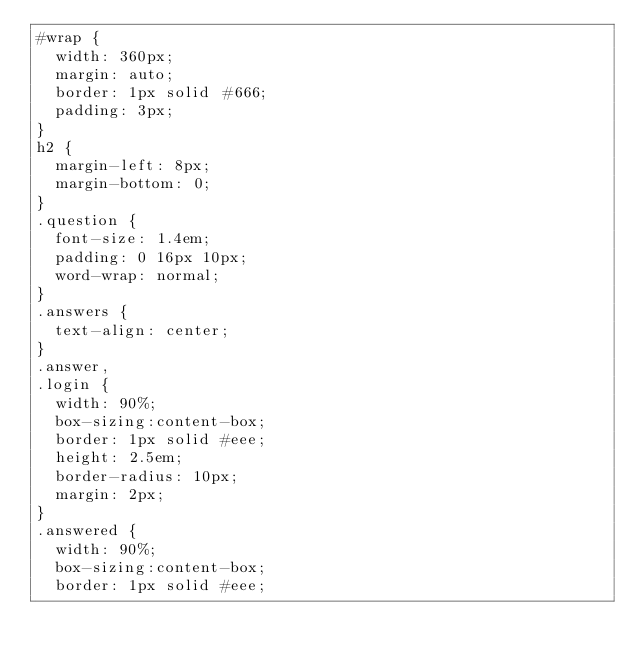Convert code to text. <code><loc_0><loc_0><loc_500><loc_500><_CSS_>#wrap {
  width: 360px;
  margin: auto;
  border: 1px solid #666;
  padding: 3px;
}
h2 {
  margin-left: 8px;
  margin-bottom: 0;
}
.question {
  font-size: 1.4em;
  padding: 0 16px 10px;
  word-wrap: normal;
}
.answers {
  text-align: center;
}
.answer,
.login {
  width: 90%;
  box-sizing:content-box;
  border: 1px solid #eee;
  height: 2.5em;
  border-radius: 10px;
  margin: 2px;
}
.answered {
  width: 90%;
  box-sizing:content-box;
  border: 1px solid #eee;</code> 